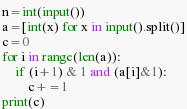Convert code to text. <code><loc_0><loc_0><loc_500><loc_500><_Python_>n=int(input())
a=[int(x) for x in input().split()]
c=0 
for i in range(len(a)):
	if (i+1) & 1 and (a[i]&1):
		c+=1 	
print(c)</code> 